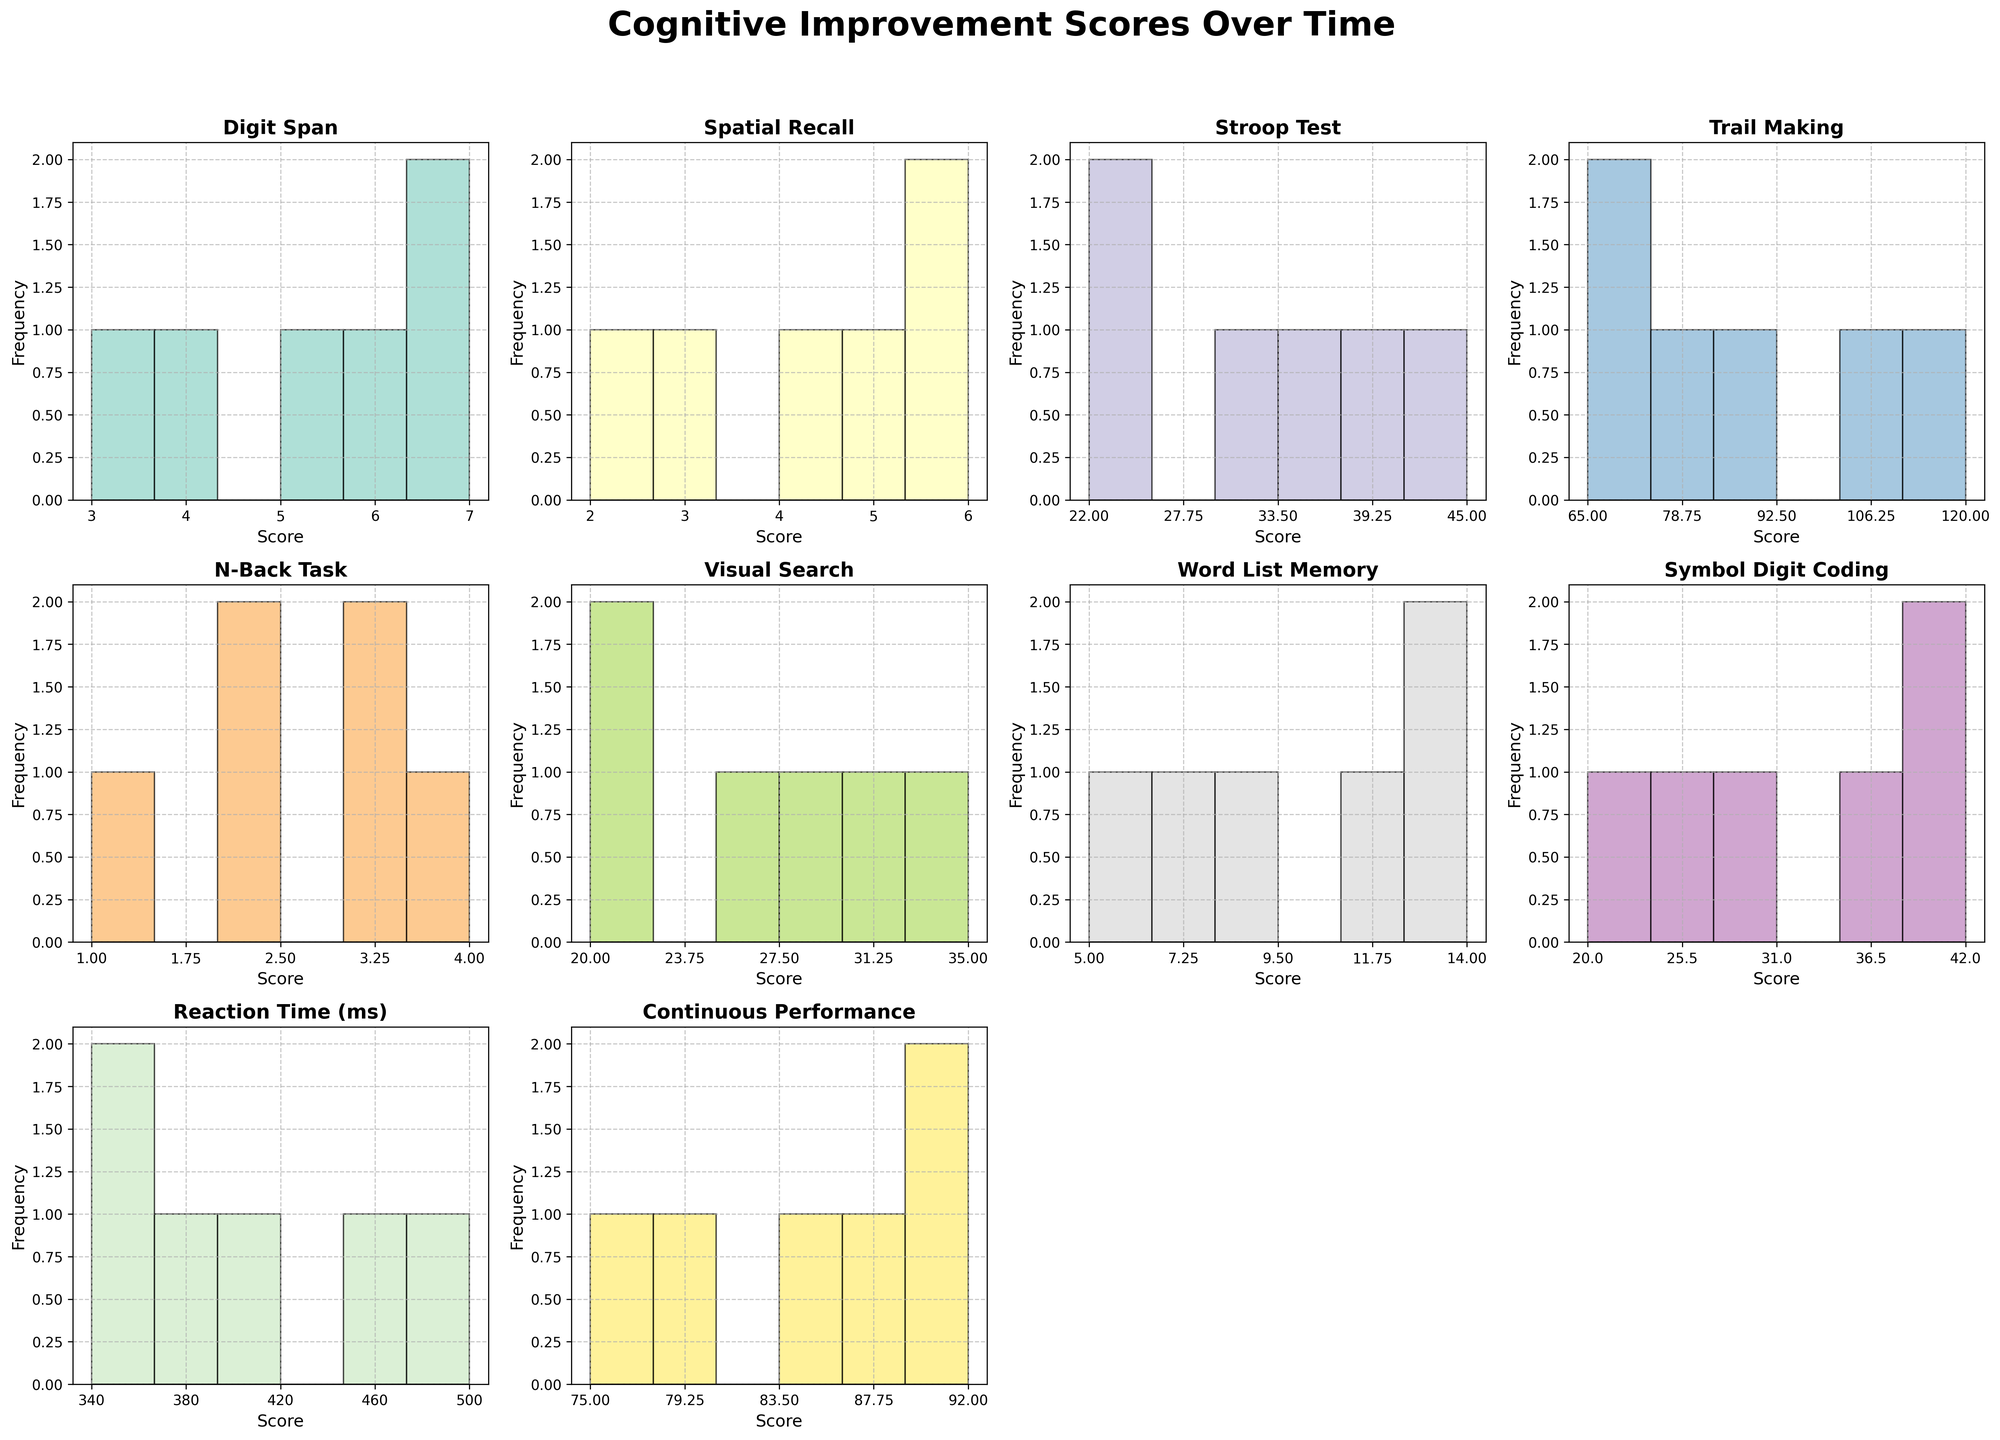What's the title of the figure? The title of the figure is usually placed at the top. Here, it reads "Cognitive Improvement Scores Over Time".
Answer: Cognitive Improvement Scores Over Time What is the color of the histogram for the "Stroop Test"? The color of the histogram bars can be identified by looking at their appearance in the subplots. The "Stroop Test" histogram uses one of the distinct colors from the Set3 colormap.
Answer: Yellow (or the exact color representation from Set3 colormap) Which task shows the highest score increase over time? To determine which task shows the highest increase, we can look at the difference between the highest and lowest scores for each task. "Word List Memory" starts from 5 and increases to 14, a total increase of 9 points.
Answer: Word List Memory What is the range of scores for the "Digit Span" task? The range is calculated by subtracting the minimum value from the maximum value. For "Digit Span", the maximum score is 7, and the minimum score is 3. Thus, 7 - 3 = 4.
Answer: 4 Which tasks have a constant or decreasing trend over time? To find tasks with a constant or decreasing trend, observe the scores over the weeks. "Stroop Test", "Trail Making", and "Visual Search" show a decreasing trend without any increase.
Answer: Stroop Test, Trail Making, Visual Search How many bins are used for the histograms in each subplot? The number of bins is set to align with the number of weeks, as indicated by the code. There are six weeks; thus each histogram uses six bins.
Answer: 6 Which task had the most diverse range of scores over the weeks? To determine the diversity, we look at the range of scores. "Reaction Time" varied from 500 to 340, showing a diverse change of 160.
Answer: Reaction Time Between "Digit Span" and "Symbol Digit Coding," which task shows a higher score after six weeks? We look at the final week scores for both tasks. "Digit Span" is 7, while "Symbol Digit Coding" is 42. Comparatively, 42 is higher than 7.
Answer: Symbol Digit Coding What is the average score for "Spatial Recall" over the six weeks? Sum the scores for "Spatial Recall" over the six weeks (2+3+4+5+6+6), which equals 26. Then divide by the number of weeks (6). The average is 26 / 6 ≈ 4.33.
Answer: ≈ 4.33 What trend is indicated by the histogram of "Continuous Performance"? The "Continuous Performance" histogram shows scores increasing gradually over the weeks. The scores rise from 75 to 92, indicating improvement over time.
Answer: Increasing trend 